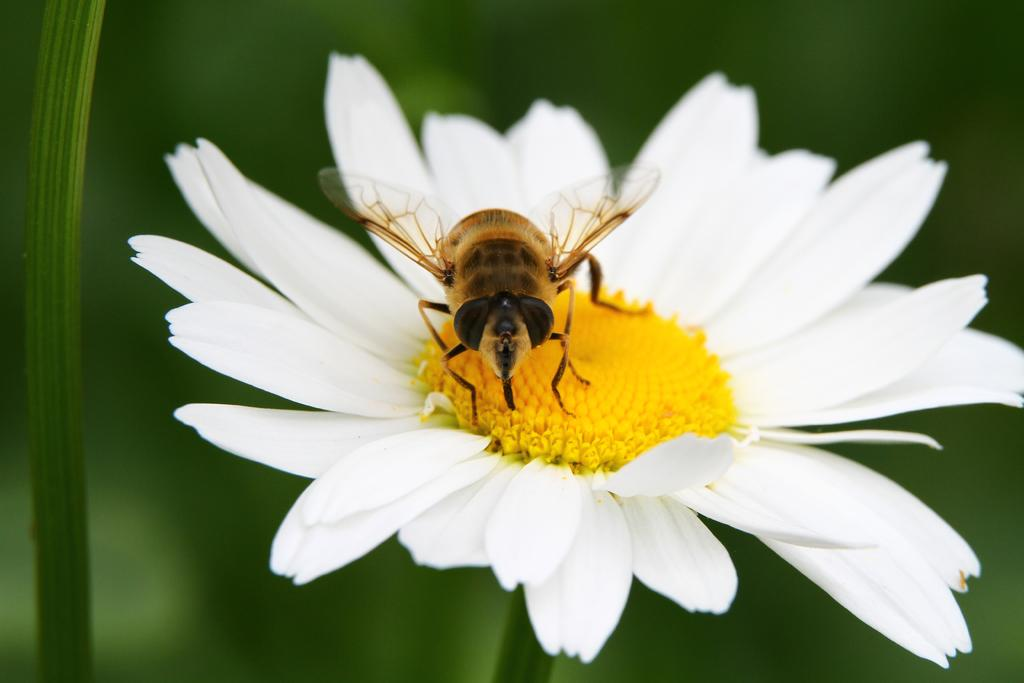What is the main subject in the foreground of the image? There is a honey bee in the foreground of the image. What is the honey bee doing in the image? The honey bee is on a white flower. What color is the background of the image? The background of the image is green. What time of day is it in the image, based on the presence of an arch? There is no arch present in the image, so it is not possible to determine the time of day based on that information. 